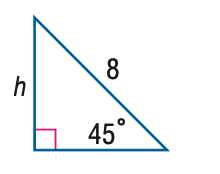Answer the mathemtical geometry problem and directly provide the correct option letter.
Question: Find h.
Choices: A: 4 B: 4 \sqrt 2 C: 4 \sqrt 3 D: 8 B 